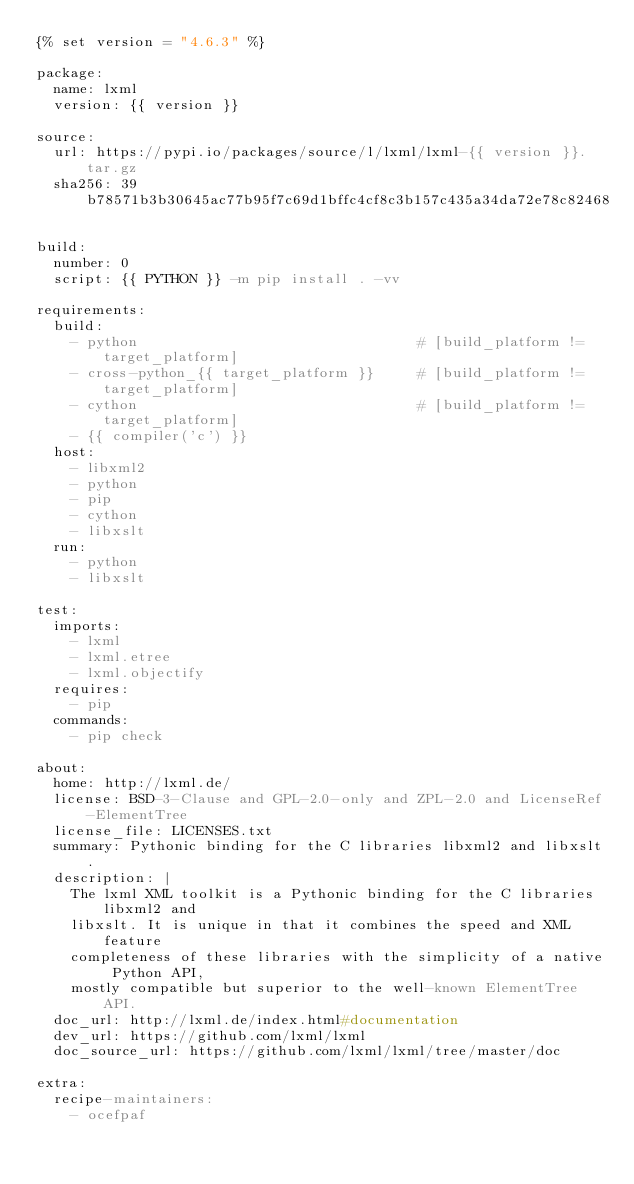Convert code to text. <code><loc_0><loc_0><loc_500><loc_500><_YAML_>{% set version = "4.6.3" %}

package:
  name: lxml
  version: {{ version }}

source:
  url: https://pypi.io/packages/source/l/lxml/lxml-{{ version }}.tar.gz
  sha256: 39b78571b3b30645ac77b95f7c69d1bffc4cf8c3b157c435a34da72e78c82468

build:
  number: 0
  script: {{ PYTHON }} -m pip install . -vv

requirements:
  build:
    - python                                 # [build_platform != target_platform]
    - cross-python_{{ target_platform }}     # [build_platform != target_platform]
    - cython                                 # [build_platform != target_platform]
    - {{ compiler('c') }}
  host:
    - libxml2
    - python
    - pip
    - cython
    - libxslt
  run:
    - python
    - libxslt

test:
  imports:
    - lxml
    - lxml.etree
    - lxml.objectify
  requires:
    - pip
  commands:
    - pip check

about:
  home: http://lxml.de/
  license: BSD-3-Clause and GPL-2.0-only and ZPL-2.0 and LicenseRef-ElementTree
  license_file: LICENSES.txt
  summary: Pythonic binding for the C libraries libxml2 and libxslt.
  description: |
    The lxml XML toolkit is a Pythonic binding for the C libraries libxml2 and
    libxslt. It is unique in that it combines the speed and XML feature
    completeness of these libraries with the simplicity of a native Python API,
    mostly compatible but superior to the well-known ElementTree API.
  doc_url: http://lxml.de/index.html#documentation
  dev_url: https://github.com/lxml/lxml
  doc_source_url: https://github.com/lxml/lxml/tree/master/doc

extra:
  recipe-maintainers:
    - ocefpaf
</code> 